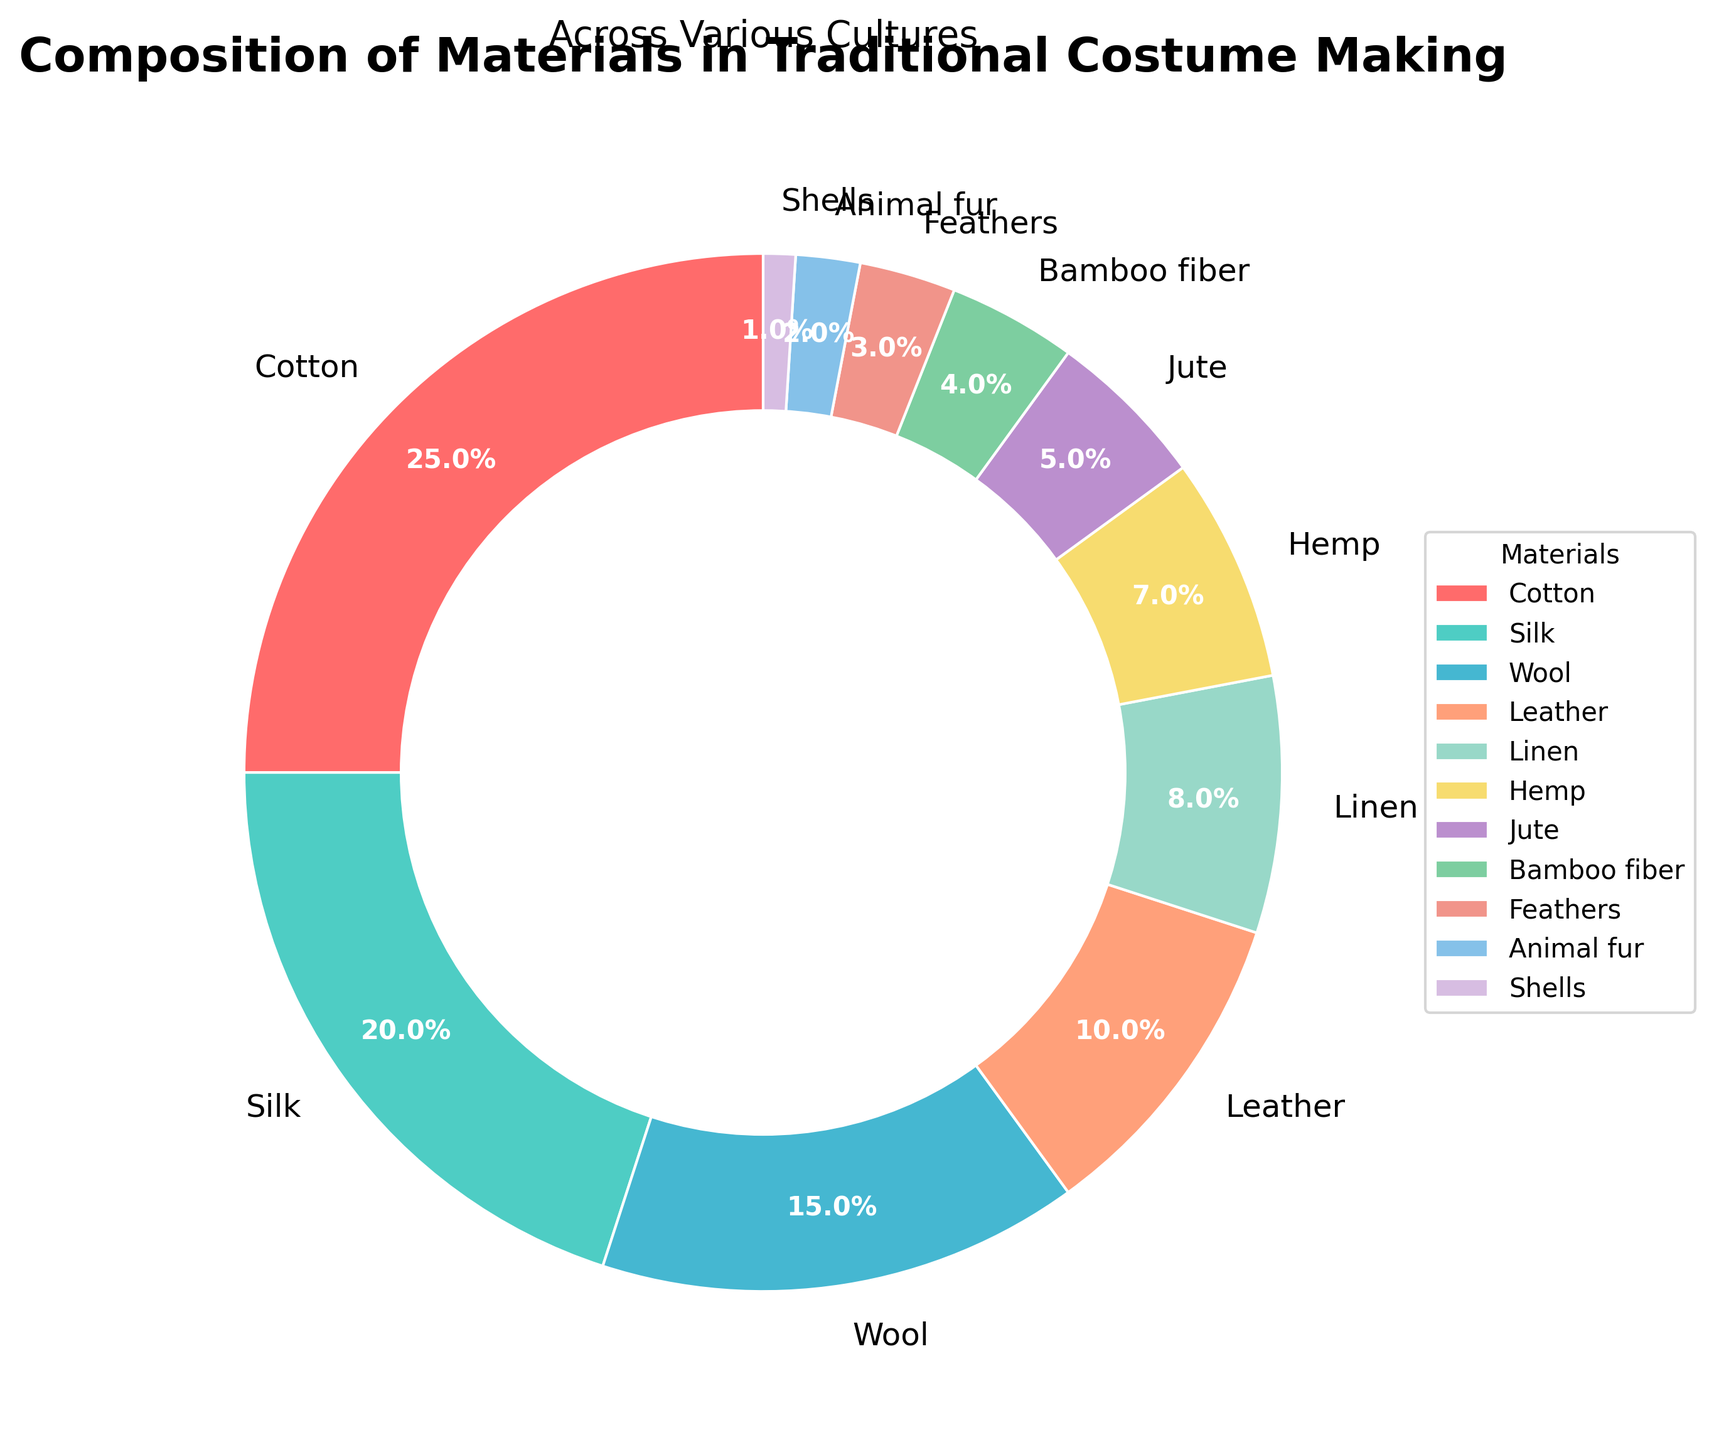What material makes up the largest portion of traditional costumes? The pie chart shows that the segment with the largest area represents 25% and is labeled "Cotton." This indicates that cotton makes up the largest portion.
Answer: Cotton Which two materials collectively account for nearly half of the materials used? Adding the percentages of the two largest segments: Cotton (25%) and Silk (20%) gives a total of 45%.
Answer: Cotton and Silk Which material is used the least in traditional costume making? The smallest segment in the pie chart, labeled with 1%, represents "Shells."
Answer: Shells How much more prevalent is Cotton compared to Wool? Cotton represents 25% while Wool represents 15%. The difference is 25% - 15% = 10%.
Answer: 10% Which materials have a percentage lower than 5%, and what is their combined percentage? The chart shows that Bamboo fiber (4%), Feathers (3%), Animal fur (2%), and Shells (1%) each have less than 5%. Added together, their total percentage is 4% + 3% + 2% + 1% = 10%.
Answer: 10% What is the visual difference between the segment representing Hemp and the segment representing Bamboo fiber? The segment representing Hemp is slightly larger than that of Bamboo fiber. Hemp is shown with 7% and Bamboo fiber with 4%.
Answer: Hemp is larger What colors are associated with the segments representing Cotton and Silk? The segment representing Cotton is the first in the list and is colored red; the segment for Silk is the second, colored turquoise.
Answer: Red for Cotton, Turquoise for Silk Which material has slightly over double the percentage of Jute? Jute has 5%, and Linen has 8%, which is slightly over double the percentage of Jute.
Answer: Linen Rank the top three materials used from highest to lowest percentage. Based on the pie chart: Cotton (25%), Silk (20%), and Wool (15%).
Answer: Cotton, Silk, Wool What fraction of the materials used are from animals (Leather, Feathers, Animal fur, Shells)? Leather (10%), Feathers (3%), Animal fur (2%), and Shells (1%) added together is 10% + 3% + 2% + 1% = 16%. So the fraction is 16/100 or simplified, 4/25.
Answer: 4/25 